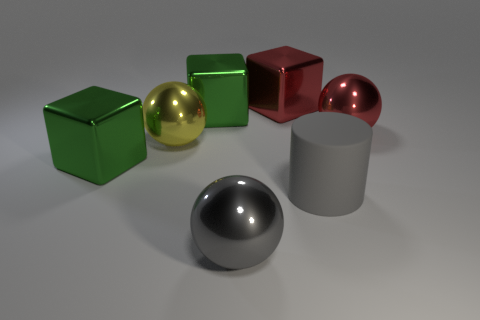Add 3 big green rubber cubes. How many objects exist? 10 Subtract all blocks. How many objects are left? 4 Add 5 large green things. How many large green things exist? 7 Subtract 0 cyan balls. How many objects are left? 7 Subtract all big gray metal cylinders. Subtract all green metal blocks. How many objects are left? 5 Add 1 metallic cubes. How many metallic cubes are left? 4 